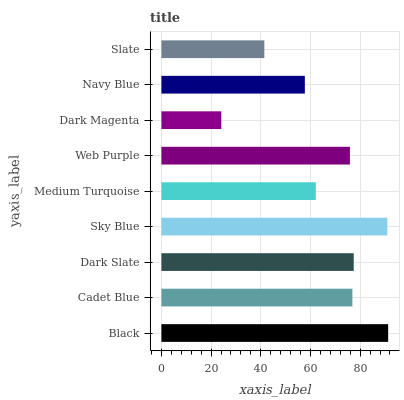Is Dark Magenta the minimum?
Answer yes or no. Yes. Is Black the maximum?
Answer yes or no. Yes. Is Cadet Blue the minimum?
Answer yes or no. No. Is Cadet Blue the maximum?
Answer yes or no. No. Is Black greater than Cadet Blue?
Answer yes or no. Yes. Is Cadet Blue less than Black?
Answer yes or no. Yes. Is Cadet Blue greater than Black?
Answer yes or no. No. Is Black less than Cadet Blue?
Answer yes or no. No. Is Web Purple the high median?
Answer yes or no. Yes. Is Web Purple the low median?
Answer yes or no. Yes. Is Medium Turquoise the high median?
Answer yes or no. No. Is Cadet Blue the low median?
Answer yes or no. No. 